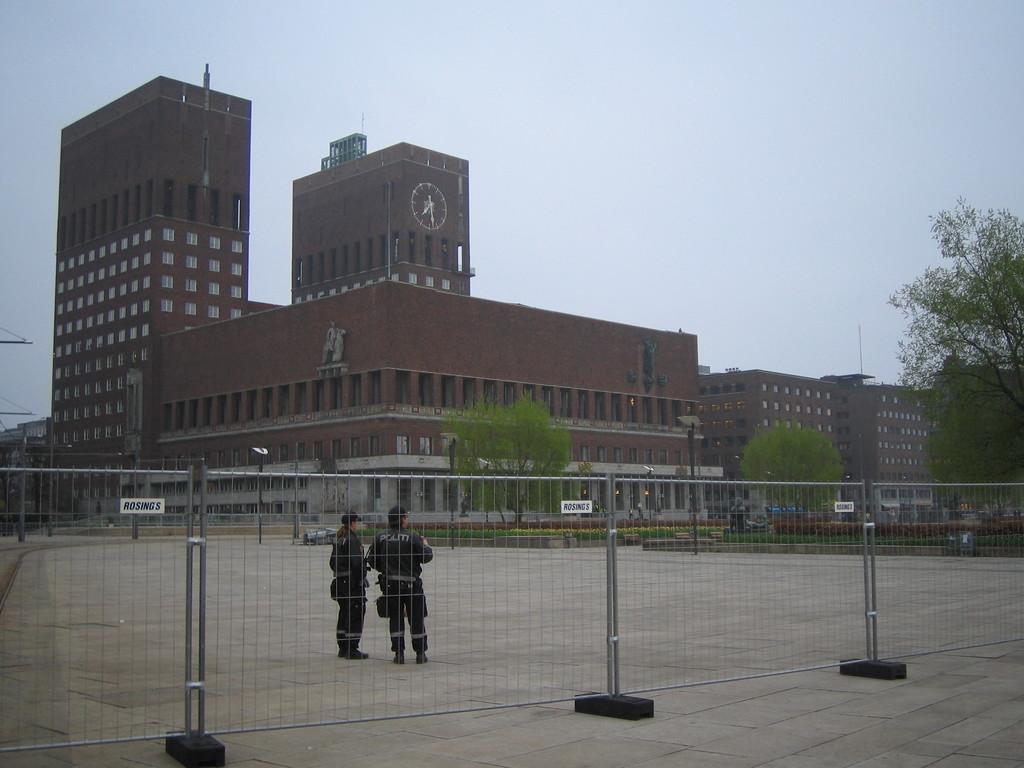How would you summarize this image in a sentence or two? In this picture we can see a fence and two people on the ground and in the background we can see buildings, trees, poles and the sky. 